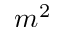Convert formula to latex. <formula><loc_0><loc_0><loc_500><loc_500>m ^ { 2 }</formula> 